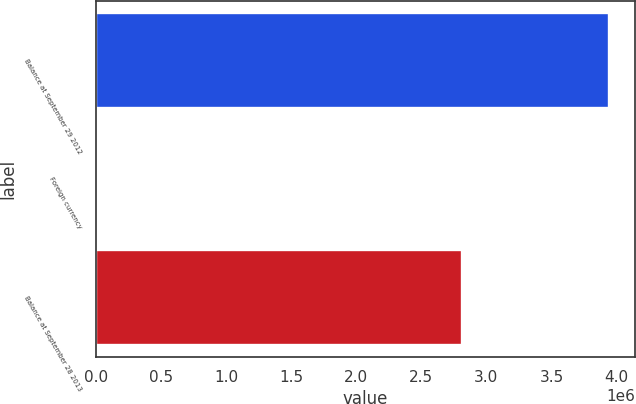Convert chart. <chart><loc_0><loc_0><loc_500><loc_500><bar_chart><fcel>Balance at September 29 2012<fcel>Foreign currency<fcel>Balance at September 28 2013<nl><fcel>3.94278e+06<fcel>265<fcel>2.81453e+06<nl></chart> 